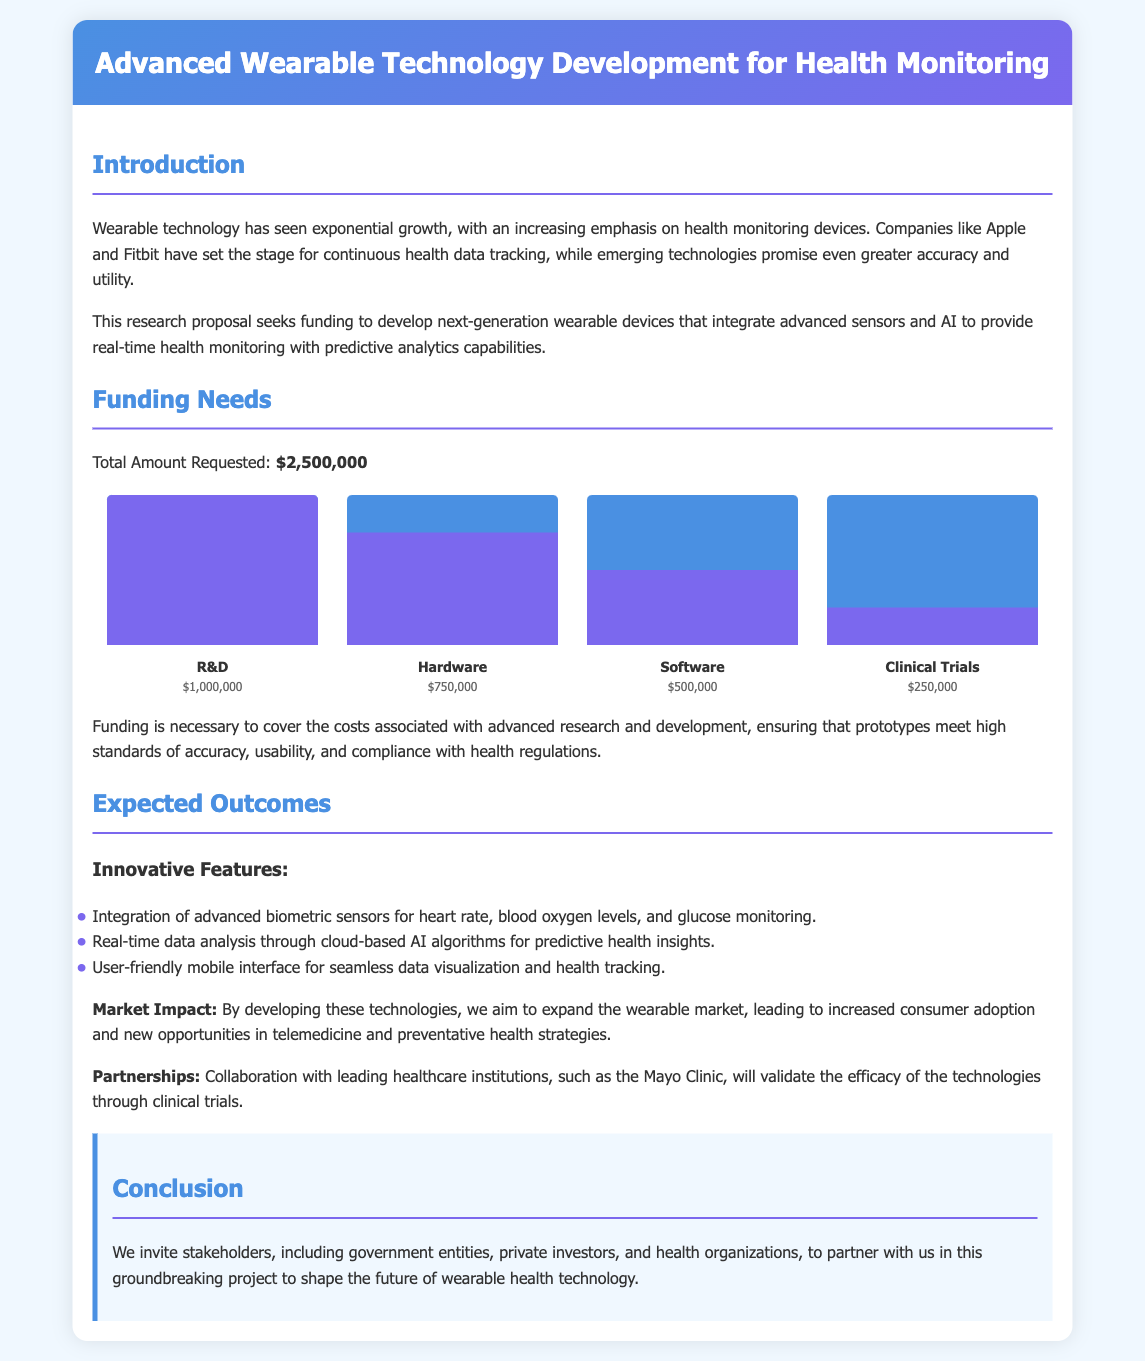What is the total amount requested? The total amount requested for the project is clearly stated in the funding needs section.
Answer: $2,500,000 What is the primary focus of the wearable technology development? The introduction outlines that the main focus is on health monitoring devices.
Answer: Health monitoring How much funding is allocated for Research and Development? The funding chart specifies the amount earmarked for Research and Development.
Answer: $1,000,000 What is one innovative feature of the proposed wearable technology? The expected outcomes section lists various innovative features, one of which is advanced biometric sensors.
Answer: Advanced biometric sensors Which institution will partner for clinical trials? The document mentions collaboration with a leading healthcare institution to validate technologies.
Answer: Mayo Clinic What percentage of funding is designated for Clinical Trials? The funding chart provides the percentage allocation for Clinical Trials in comparison to total funding.
Answer: 10% What is the expected market impact mentioned in the proposal? The expected outcomes section describes the anticipated effects on consumer adoption and market growth.
Answer: Increased consumer adoption How much funding is allocated for Hardware? The funding chart outlines the specific funding amount allocated to Hardware.
Answer: $750,000 What is the purpose of the proposed research project? The introduction states the purpose is to develop next-generation wearable devices with specific capabilities.
Answer: Develop next-generation wearable devices 